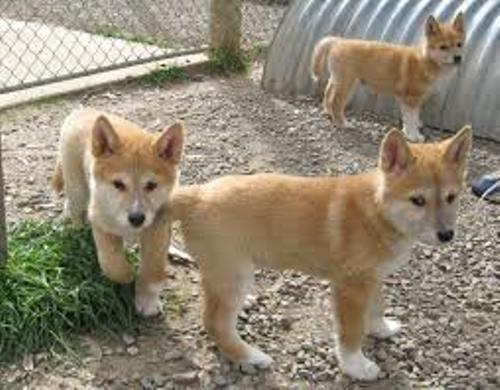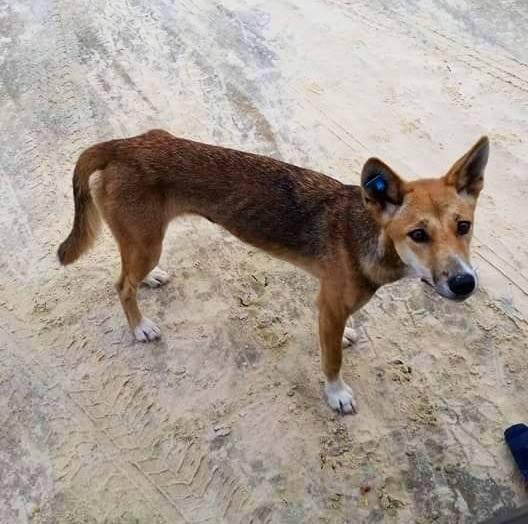The first image is the image on the left, the second image is the image on the right. Analyze the images presented: Is the assertion "There are exactly four animals in the pair of images with at least three of them standing." valid? Answer yes or no. Yes. The first image is the image on the left, the second image is the image on the right. Considering the images on both sides, is "The combined images contain a total of four dingos, and at least three of the dogs are standing." valid? Answer yes or no. Yes. 